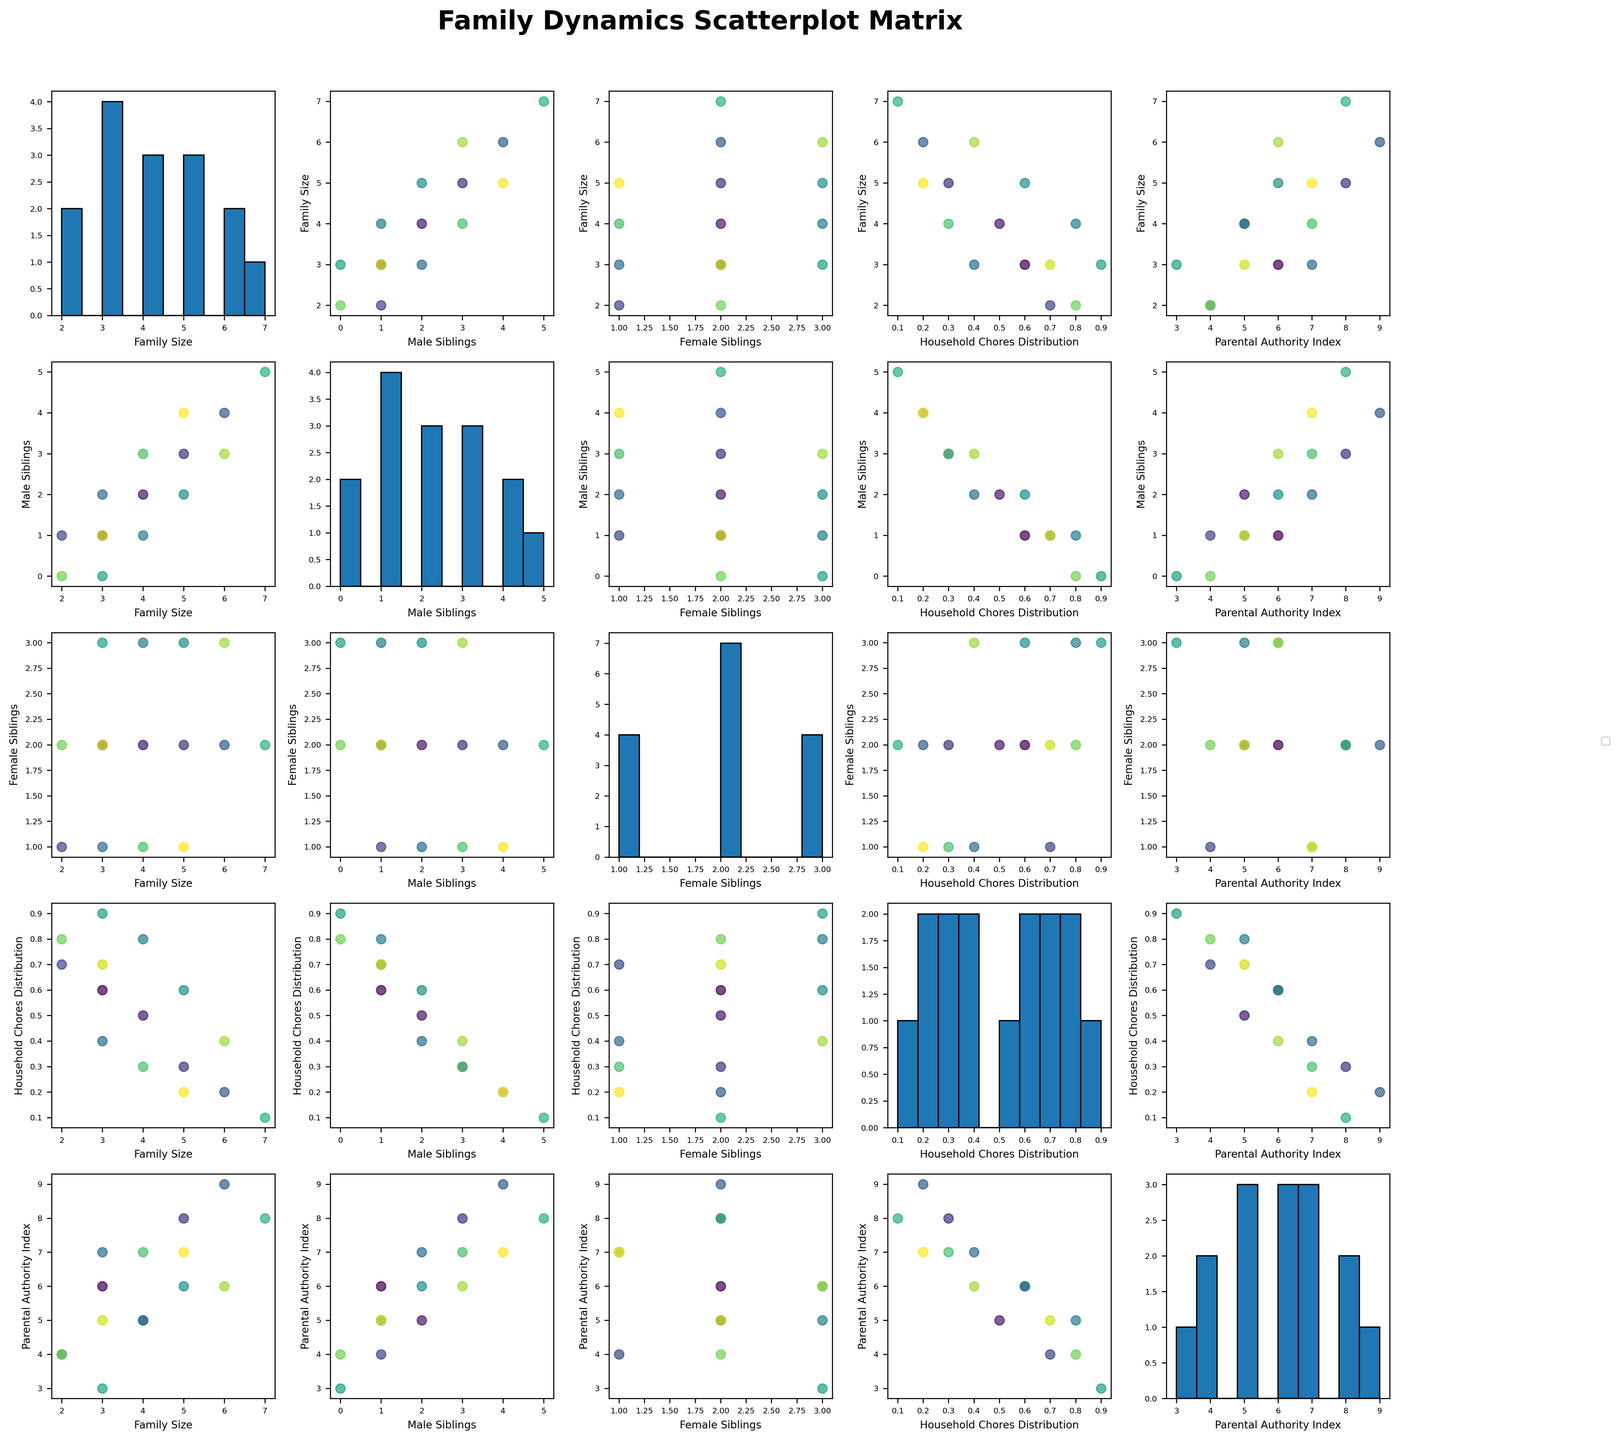What is the title of the scatterplot matrix? The title of the scatterplot matrix is written above the plot. It says "Family Dynamics Scatterplot Matrix".
Answer: Family Dynamics Scatterplot Matrix Which cultural context has households with the highest Family Size? By inspecting the scatter plots, Nigeria shows the highest Family Size with seven members.
Answer: Nigeria How is the distribution of Household Chores in the Netherlands compared to Denmark? The scatter plot for Household Chores Distribution and Cultural Context shows that the Netherlands has a median value of 0.8, while Denmark has 0.9. Denmark has a higher distribution.
Answer: Denmark What is the median value of Parental Authority Index in the dataset? By examining the histogram for the Parental Authority Index, we observe its distribution. It has a median value around 6.
Answer: 6 Do households in Japan and the UK have more male or female siblings? By checking the scatter plots for Japan and the UK in terms of Male and Female Siblings, Japan has more male siblings while the UK has an equal number of male and female siblings.
Answer: Male in Japan, Equal in UK Which country has evenly distributed Household Chores between male and female siblings? In the scatter plot relating Household Chores Distribution to Cultural Context, the UK shows a balanced distribution with a value of 0.5.
Answer: UK What is the maximum value of Family Size, and which cultural context does it belong to? The scatter plot for Family Size shows that the highest value is 7, which belongs to Nigeria.
Answer: 7, Nigeria How does household chores distribution vary with family size across different cultures? By viewing scatter plots of Household Chores Distribution vs. Family Size, we see that greater family sizes like Nigeria (7 members) have lower distribution values around 0.1, whereas smaller sizes like Denmark or Netherlands (2-3 members) have higher distribution values (0.8-0.9).
Answer: Larger families tend to have lower distribution values, smaller families tend to have higher values Is there any cultural context with a high number of male siblings but a low number of female siblings? In the scatter plots, Saudi Arabia shows 4 male siblings and 2 female siblings, satisfying the given condition.
Answer: Saudi Arabia 